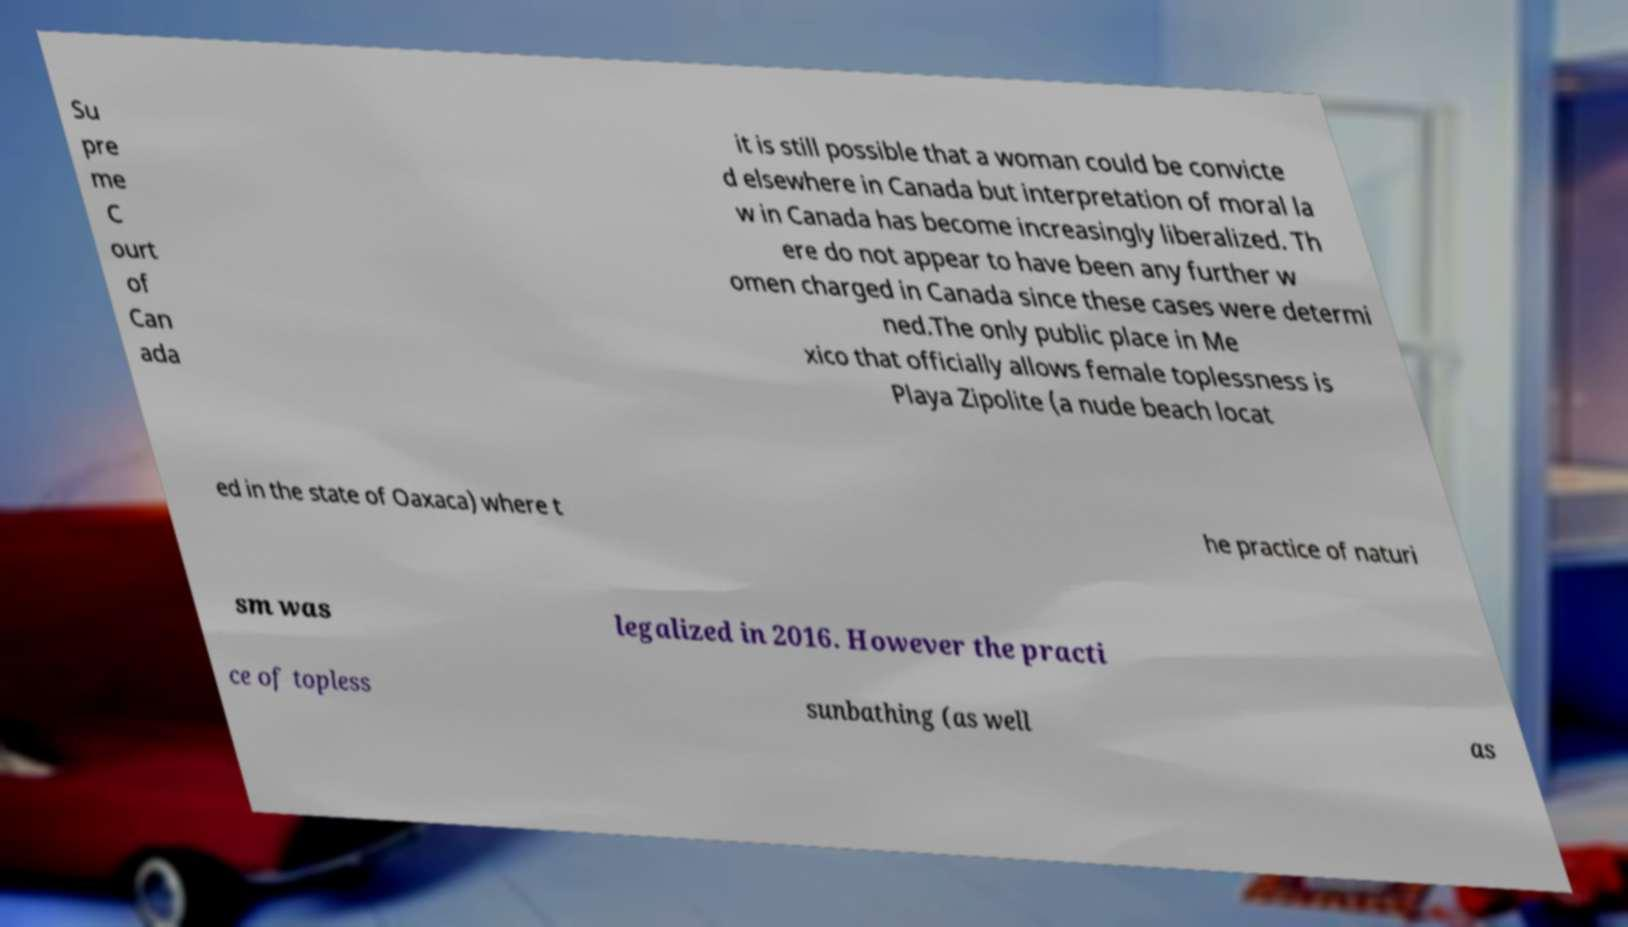I need the written content from this picture converted into text. Can you do that? Su pre me C ourt of Can ada it is still possible that a woman could be convicte d elsewhere in Canada but interpretation of moral la w in Canada has become increasingly liberalized. Th ere do not appear to have been any further w omen charged in Canada since these cases were determi ned.The only public place in Me xico that officially allows female toplessness is Playa Zipolite (a nude beach locat ed in the state of Oaxaca) where t he practice of naturi sm was legalized in 2016. However the practi ce of topless sunbathing (as well as 